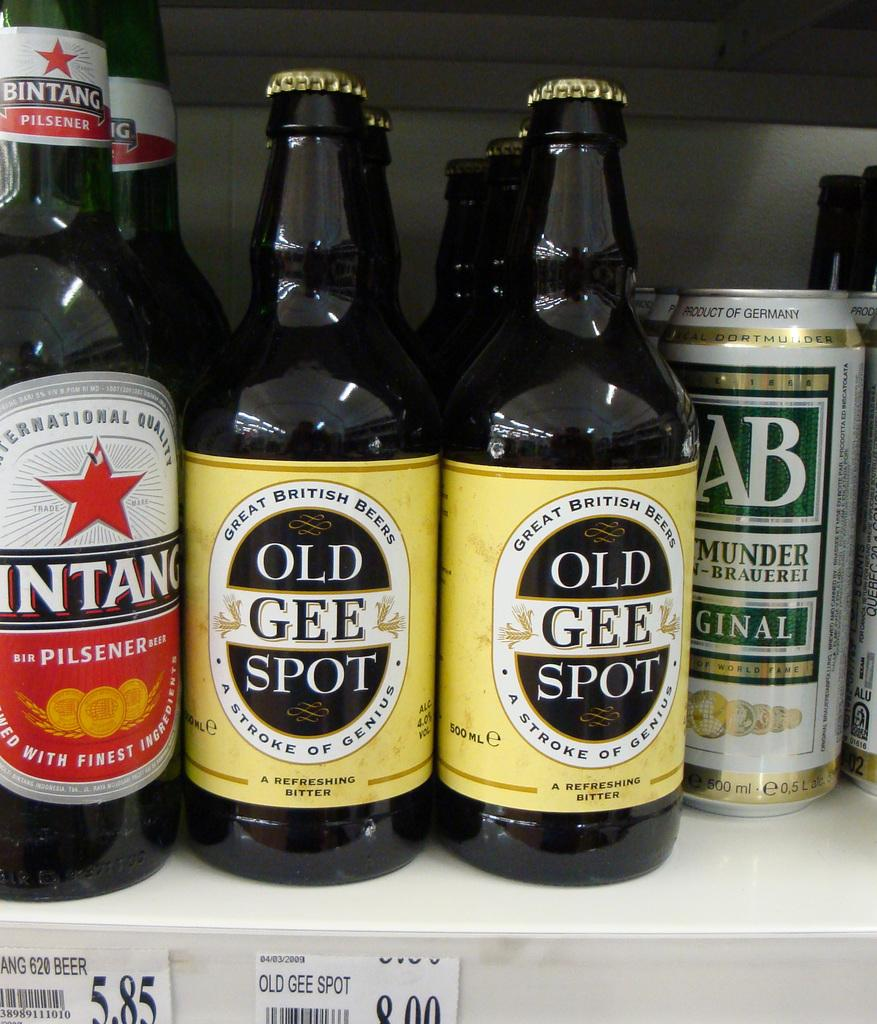Provide a one-sentence caption for the provided image. Two Great British Bees Old Gee Spot, Bintang Pilsener, and cans of Ginalon on a shelf. 